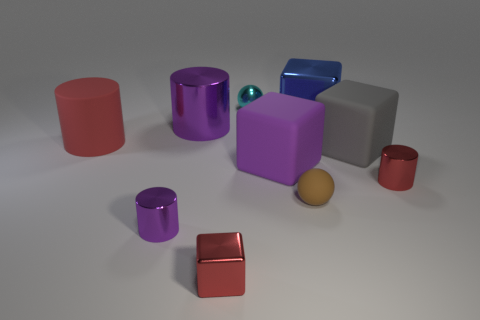Subtract 1 cylinders. How many cylinders are left? 3 Subtract all spheres. How many objects are left? 8 Add 4 purple matte objects. How many purple matte objects exist? 5 Subtract 0 blue cylinders. How many objects are left? 10 Subtract all small red blocks. Subtract all big blue metallic things. How many objects are left? 8 Add 9 large blue metal objects. How many large blue metal objects are left? 10 